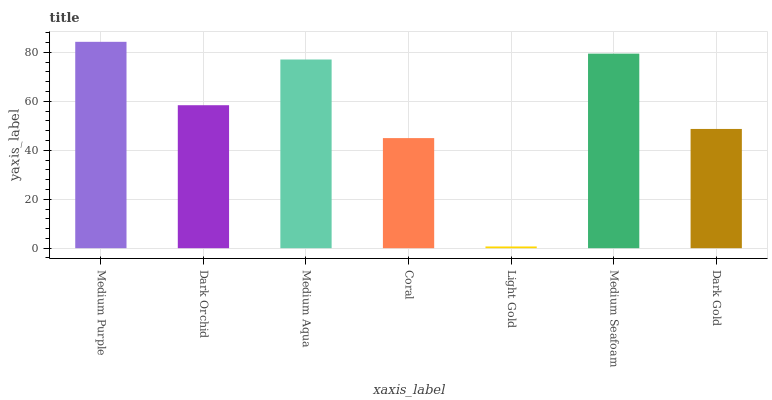Is Dark Orchid the minimum?
Answer yes or no. No. Is Dark Orchid the maximum?
Answer yes or no. No. Is Medium Purple greater than Dark Orchid?
Answer yes or no. Yes. Is Dark Orchid less than Medium Purple?
Answer yes or no. Yes. Is Dark Orchid greater than Medium Purple?
Answer yes or no. No. Is Medium Purple less than Dark Orchid?
Answer yes or no. No. Is Dark Orchid the high median?
Answer yes or no. Yes. Is Dark Orchid the low median?
Answer yes or no. Yes. Is Medium Aqua the high median?
Answer yes or no. No. Is Dark Gold the low median?
Answer yes or no. No. 